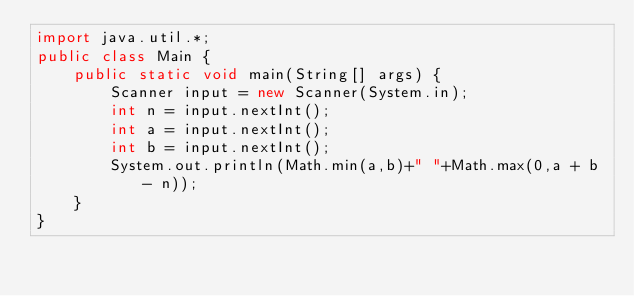Convert code to text. <code><loc_0><loc_0><loc_500><loc_500><_Java_>import java.util.*;
public class Main {
    public static void main(String[] args) {
        Scanner input = new Scanner(System.in);
        int n = input.nextInt();
        int a = input.nextInt();
        int b = input.nextInt();
        System.out.println(Math.min(a,b)+" "+Math.max(0,a + b - n));
    }
}</code> 